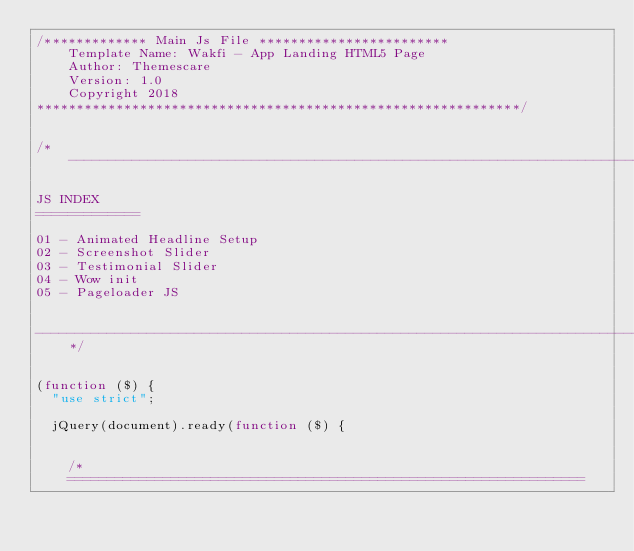<code> <loc_0><loc_0><loc_500><loc_500><_JavaScript_>/************* Main Js File ************************
    Template Name: Wakfi - App Landing HTML5 Page
    Author: Themescare
    Version: 1.0
    Copyright 2018
*************************************************************/


/*------------------------------------------------------------------------------------
    
JS INDEX
=============

01 - Animated Headline Setup
02 - Screenshot Slider
03 - Testimonial Slider
04 - Wow init
05 - Pageloader JS


-------------------------------------------------------------------------------------*/


(function ($) {
	"use strict";

	jQuery(document).ready(function ($) {


		/* 
		=================================================================</code> 